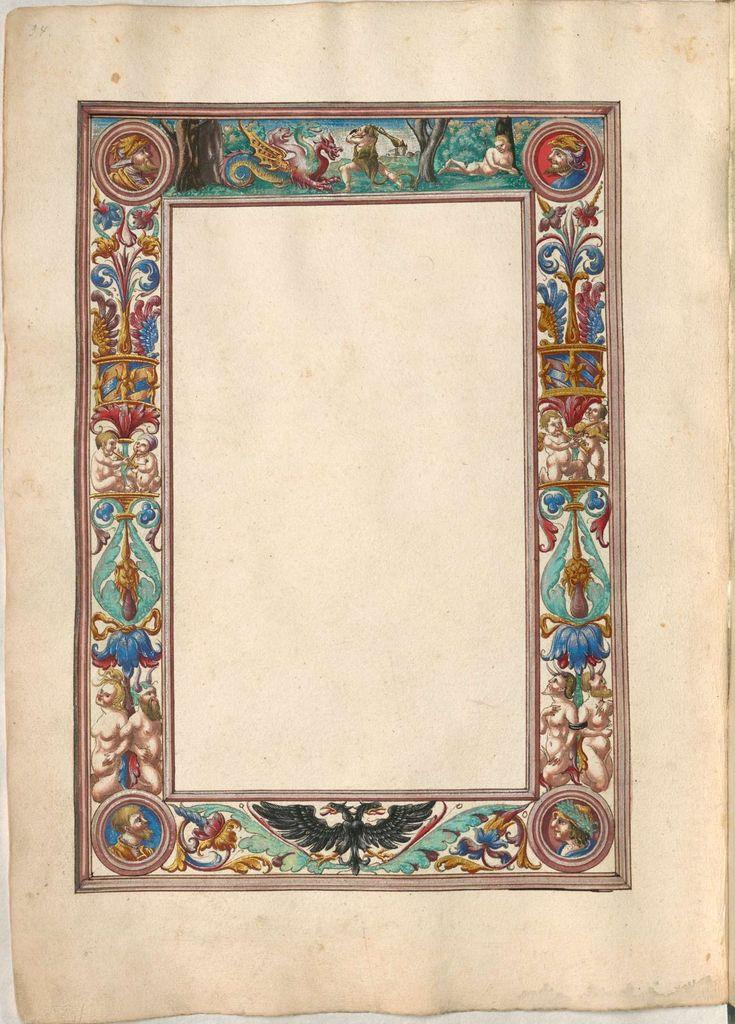What is the main color of the object in the image? The main color of the object in the image is cream. What can be seen on the surface of the object? The object has different types of colorful paintings on it. What is the route to the bridge in the image? There is no route or bridge present in the image; it only features a cream-colored object with colorful paintings on it. 